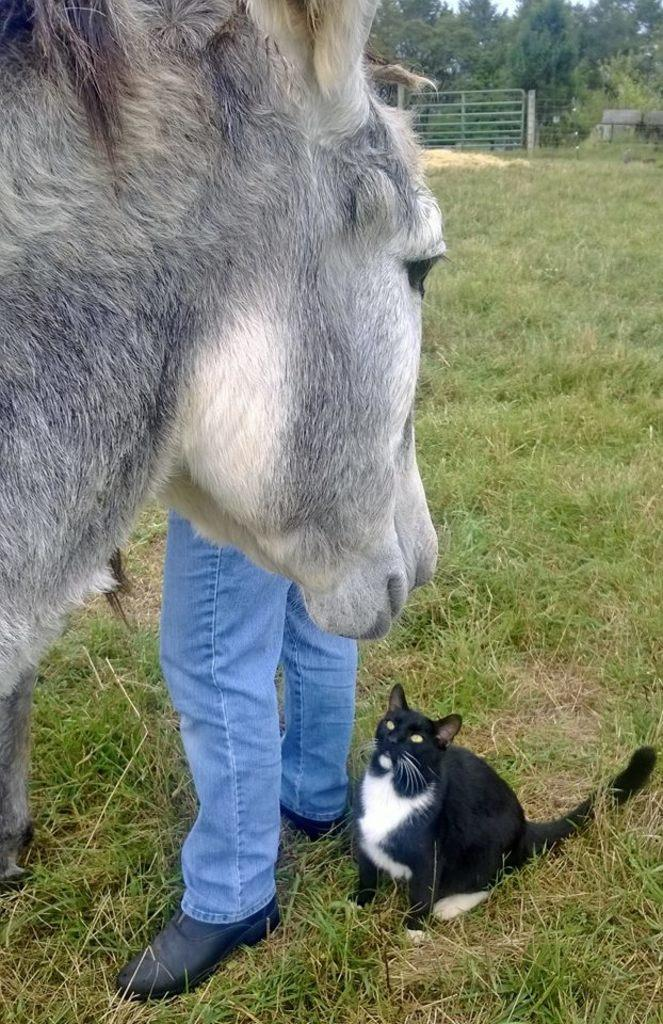How many animals are present in the image? There are two animals in the image. What is the person in the image doing? A: The person is standing on the ground in the image. What can be seen in the background of the image? There is a metal gate and a group of trees in the background of the image. What type of celery is the person holding in the image? There is no celery present in the image; the person is not holding any vegetables. 